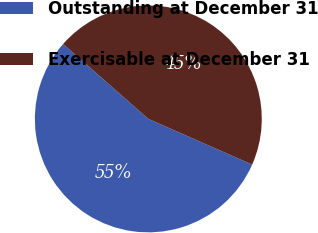<chart> <loc_0><loc_0><loc_500><loc_500><pie_chart><fcel>Outstanding at December 31<fcel>Exercisable at December 31<nl><fcel>54.88%<fcel>45.12%<nl></chart> 